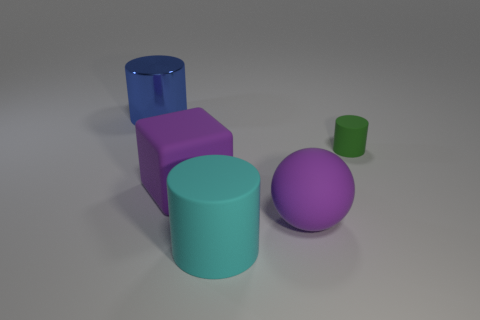Is there anything else that is the same material as the big blue cylinder?
Your answer should be compact. No. Does the cylinder that is behind the small green thing have the same color as the small cylinder?
Provide a succinct answer. No. What size is the cylinder that is both left of the small green object and in front of the large blue thing?
Keep it short and to the point. Large. How many large objects are either blue cylinders or purple spheres?
Ensure brevity in your answer.  2. There is a small thing that is behind the large cyan object; what is its shape?
Your answer should be very brief. Cylinder. How many large purple spheres are there?
Ensure brevity in your answer.  1. Do the purple sphere and the block have the same material?
Give a very brief answer. Yes. Is the number of big rubber spheres that are left of the big sphere greater than the number of small blue shiny spheres?
Your answer should be compact. No. What number of objects are tiny purple metal cylinders or large objects that are left of the big cyan thing?
Provide a succinct answer. 2. Is the number of big blue objects that are in front of the purple ball greater than the number of cyan rubber cylinders on the left side of the small rubber cylinder?
Ensure brevity in your answer.  No. 